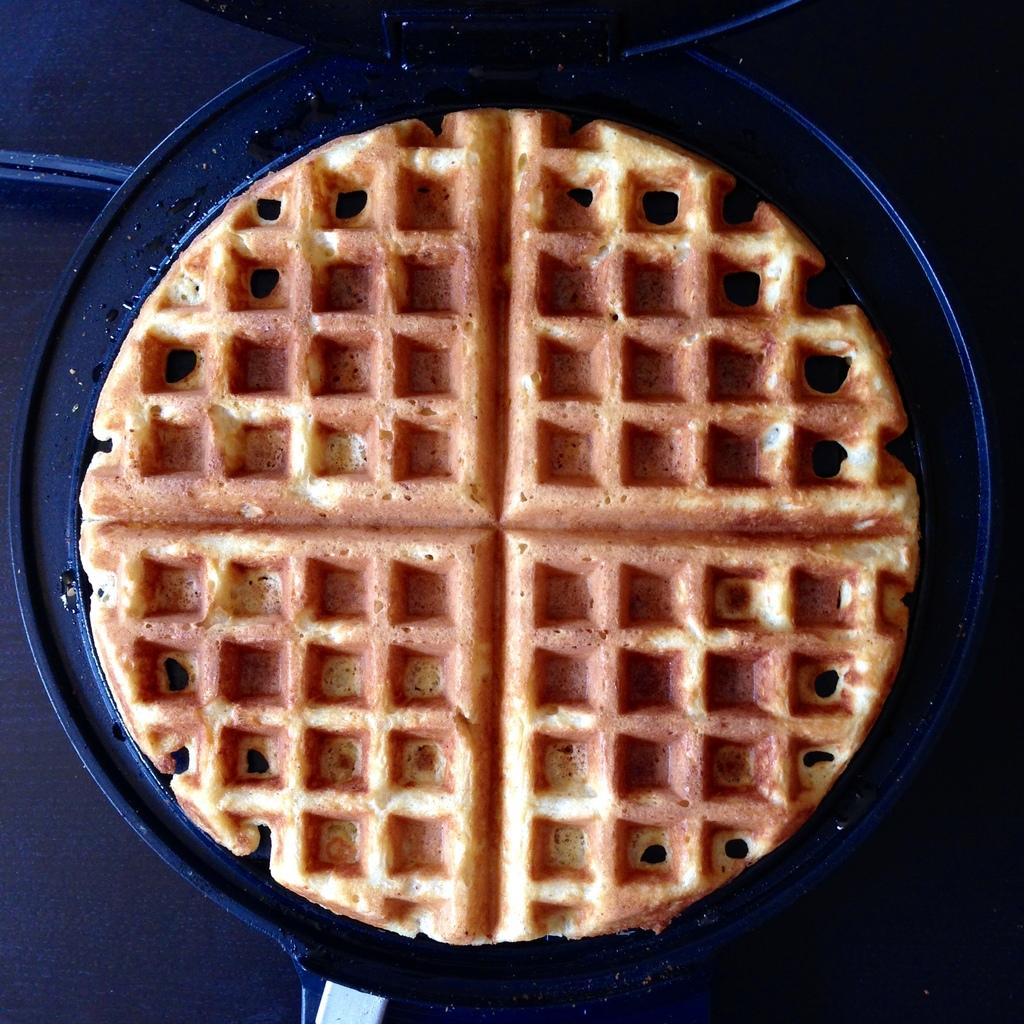What type of food is visible in the image? There is a bread in the image. How is the bread being prepared or served? The bread is in a pan. What is the color of the table where the pan is placed? The pan is placed on a black table. How many pockets are visible on the bread in the image? There are no pockets visible on the bread in the image, as bread typically does not have pockets. 